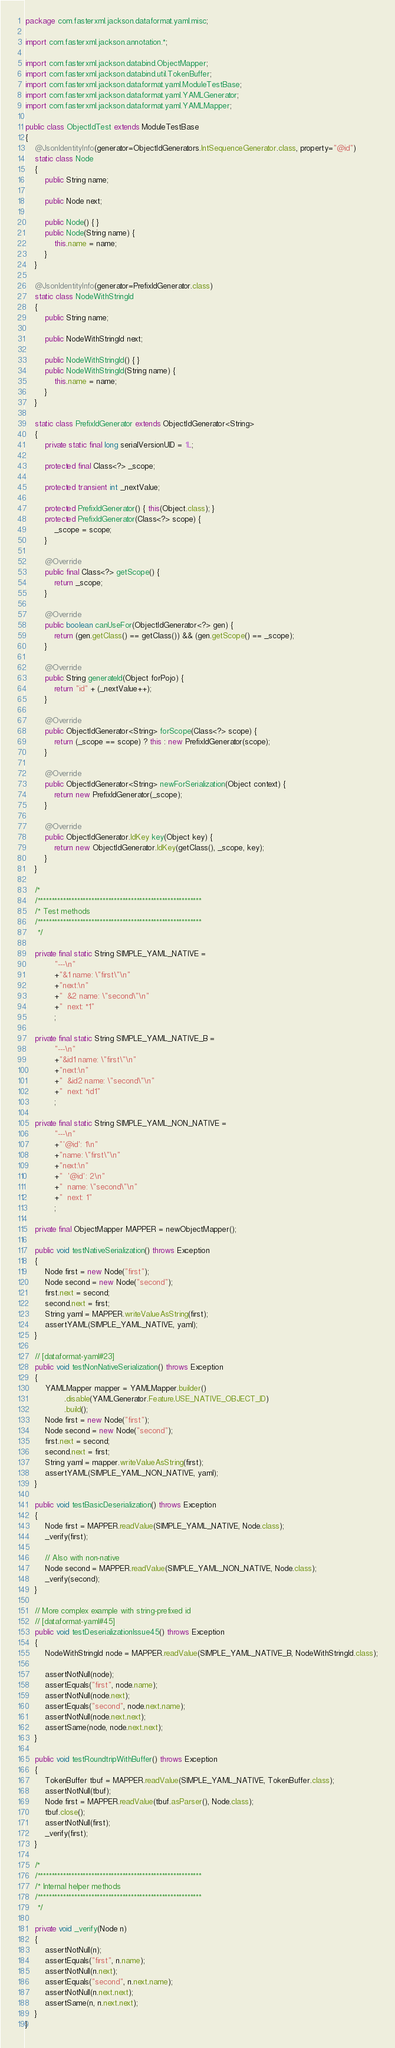Convert code to text. <code><loc_0><loc_0><loc_500><loc_500><_Java_>package com.fasterxml.jackson.dataformat.yaml.misc;

import com.fasterxml.jackson.annotation.*;

import com.fasterxml.jackson.databind.ObjectMapper;
import com.fasterxml.jackson.databind.util.TokenBuffer;
import com.fasterxml.jackson.dataformat.yaml.ModuleTestBase;
import com.fasterxml.jackson.dataformat.yaml.YAMLGenerator;
import com.fasterxml.jackson.dataformat.yaml.YAMLMapper;

public class ObjectIdTest extends ModuleTestBase
{
    @JsonIdentityInfo(generator=ObjectIdGenerators.IntSequenceGenerator.class, property="@id")
    static class Node
    {
        public String name;

        public Node next;
        
        public Node() { }
        public Node(String name) {
            this.name = name;
        }
    }

    @JsonIdentityInfo(generator=PrefixIdGenerator.class)
    static class NodeWithStringId
    {
        public String name;

        public NodeWithStringId next;
        
        public NodeWithStringId() { }
        public NodeWithStringId(String name) {
            this.name = name;
        }
    }
    
    static class PrefixIdGenerator extends ObjectIdGenerator<String>
    {
        private static final long serialVersionUID = 1L;

        protected final Class<?> _scope;

        protected transient int _nextValue;

        protected PrefixIdGenerator() { this(Object.class); }
        protected PrefixIdGenerator(Class<?> scope) {
            _scope = scope;
        }

        @Override
        public final Class<?> getScope() {
            return _scope;
        }
        
        @Override
        public boolean canUseFor(ObjectIdGenerator<?> gen) {
            return (gen.getClass() == getClass()) && (gen.getScope() == _scope);
        }

        @Override
        public String generateId(Object forPojo) {
            return "id" + (_nextValue++);
        }

        @Override
        public ObjectIdGenerator<String> forScope(Class<?> scope) {
            return (_scope == scope) ? this : new PrefixIdGenerator(scope);
        }

        @Override
        public ObjectIdGenerator<String> newForSerialization(Object context) {
            return new PrefixIdGenerator(_scope);
        }

        @Override
        public ObjectIdGenerator.IdKey key(Object key) {
            return new ObjectIdGenerator.IdKey(getClass(), _scope, key);
        }
    }
    
    /*
    /**********************************************************
    /* Test methods
    /**********************************************************
     */

    private final static String SIMPLE_YAML_NATIVE =
            "---\n"
            +"&1 name: \"first\"\n"
            +"next:\n"
            +"  &2 name: \"second\"\n"
            +"  next: *1"
            ;

    private final static String SIMPLE_YAML_NATIVE_B =
            "---\n"
            +"&id1 name: \"first\"\n"
            +"next:\n"
            +"  &id2 name: \"second\"\n"
            +"  next: *id1"
            ;
    
    private final static String SIMPLE_YAML_NON_NATIVE =
            "---\n"
            +"'@id': 1\n"
            +"name: \"first\"\n"
            +"next:\n"
            +"  '@id': 2\n"
            +"  name: \"second\"\n"
            +"  next: 1"
            ;

    private final ObjectMapper MAPPER = newObjectMapper();

    public void testNativeSerialization() throws Exception
    {
        Node first = new Node("first");
        Node second = new Node("second");
        first.next = second;
        second.next = first;
        String yaml = MAPPER.writeValueAsString(first);
        assertYAML(SIMPLE_YAML_NATIVE, yaml);
    }

    // [dataformat-yaml#23]
    public void testNonNativeSerialization() throws Exception
    {
        YAMLMapper mapper = YAMLMapper.builder()
                .disable(YAMLGenerator.Feature.USE_NATIVE_OBJECT_ID)
                .build();
        Node first = new Node("first");
        Node second = new Node("second");
        first.next = second;
        second.next = first;
        String yaml = mapper.writeValueAsString(first);
        assertYAML(SIMPLE_YAML_NON_NATIVE, yaml);
    }

    public void testBasicDeserialization() throws Exception
    {
        Node first = MAPPER.readValue(SIMPLE_YAML_NATIVE, Node.class);
        _verify(first);

        // Also with non-native
        Node second = MAPPER.readValue(SIMPLE_YAML_NON_NATIVE, Node.class);
        _verify(second);
    }

    // More complex example with string-prefixed id
    // [dataformat-yaml#45]
    public void testDeserializationIssue45() throws Exception
    {
        NodeWithStringId node = MAPPER.readValue(SIMPLE_YAML_NATIVE_B, NodeWithStringId.class);

        assertNotNull(node);
        assertEquals("first", node.name);
        assertNotNull(node.next);
        assertEquals("second", node.next.name);
        assertNotNull(node.next.next);
        assertSame(node, node.next.next);
    }

    public void testRoundtripWithBuffer() throws Exception
    {
        TokenBuffer tbuf = MAPPER.readValue(SIMPLE_YAML_NATIVE, TokenBuffer.class);
        assertNotNull(tbuf);
        Node first = MAPPER.readValue(tbuf.asParser(), Node.class);
        tbuf.close();
        assertNotNull(first);
        _verify(first);
    }

    /*
    /**********************************************************
    /* Internal helper methods
    /**********************************************************
     */

    private void _verify(Node n)
    {
        assertNotNull(n);
        assertEquals("first", n.name);
        assertNotNull(n.next);
        assertEquals("second", n.next.name);
        assertNotNull(n.next.next);
        assertSame(n, n.next.next);
    }
}
</code> 